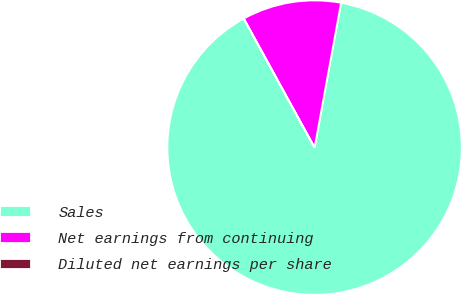Convert chart. <chart><loc_0><loc_0><loc_500><loc_500><pie_chart><fcel>Sales<fcel>Net earnings from continuing<fcel>Diluted net earnings per share<nl><fcel>89.12%<fcel>10.86%<fcel>0.02%<nl></chart> 